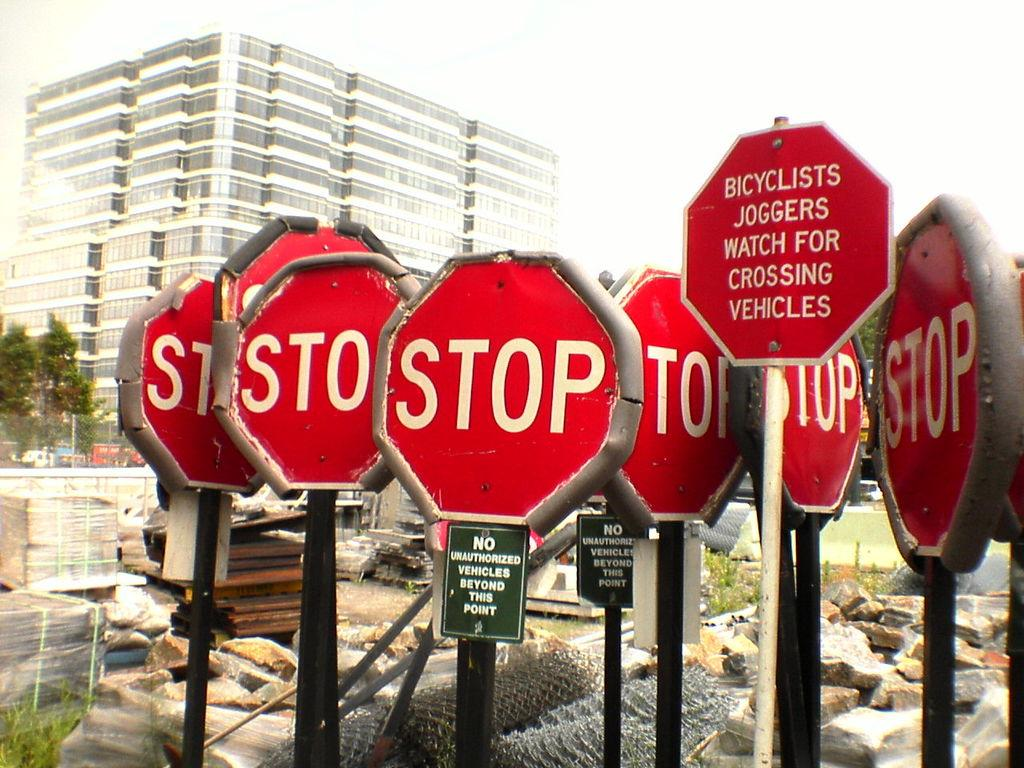<image>
Summarize the visual content of the image. Several red stop signs are close together along with warnings for bicyclists. 